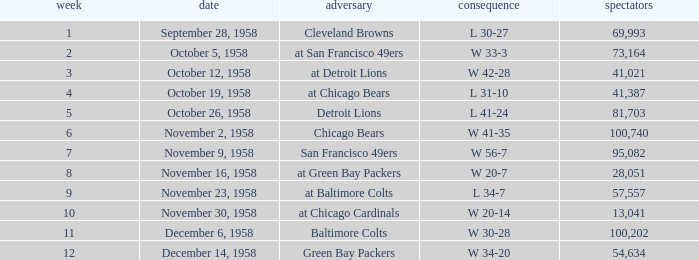What was the higest attendance on November 9, 1958? 95082.0. 